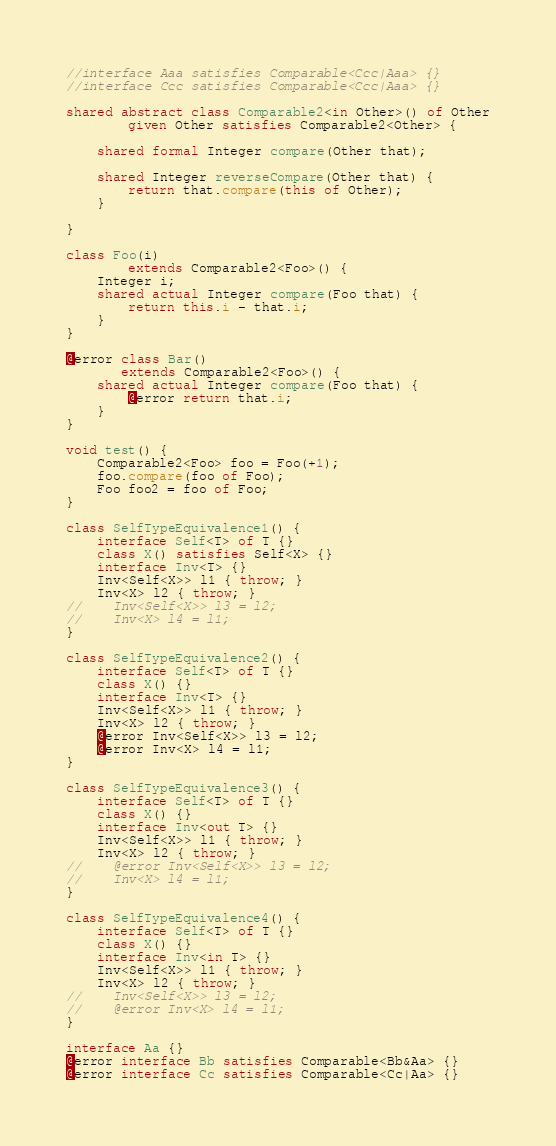Convert code to text. <code><loc_0><loc_0><loc_500><loc_500><_Ceylon_>//interface Aaa satisfies Comparable<Ccc|Aaa> {}
//interface Ccc satisfies Comparable<Ccc|Aaa> {}

shared abstract class Comparable2<in Other>() of Other
        given Other satisfies Comparable2<Other> {
    
    shared formal Integer compare(Other that);
    
    shared Integer reverseCompare(Other that) { 
        return that.compare(this of Other);
    }
    
}

class Foo(i)
        extends Comparable2<Foo>() {
    Integer i;
    shared actual Integer compare(Foo that) {
        return this.i - that.i;
    }
}

@error class Bar()
       extends Comparable2<Foo>() {
    shared actual Integer compare(Foo that) {
        @error return that.i;
    }
}

void test() {
    Comparable2<Foo> foo = Foo(+1);
    foo.compare(foo of Foo);
    Foo foo2 = foo of Foo;
}

class SelfTypeEquivalence1() {
    interface Self<T> of T {}
    class X() satisfies Self<X> {}
    interface Inv<T> {}
    Inv<Self<X>> l1 { throw; }
    Inv<X> l2 { throw; }
//    Inv<Self<X>> l3 = l2;
//    Inv<X> l4 = l1;
}

class SelfTypeEquivalence2() {
    interface Self<T> of T {}
    class X() {}
    interface Inv<T> {}
    Inv<Self<X>> l1 { throw; }
    Inv<X> l2 { throw; }
    @error Inv<Self<X>> l3 = l2;
    @error Inv<X> l4 = l1;
}

class SelfTypeEquivalence3() {
    interface Self<T> of T {}
    class X() {}
    interface Inv<out T> {}
    Inv<Self<X>> l1 { throw; }
    Inv<X> l2 { throw; }
//    @error Inv<Self<X>> l3 = l2;
//    Inv<X> l4 = l1;
}

class SelfTypeEquivalence4() {
    interface Self<T> of T {}
    class X() {}
    interface Inv<in T> {}
    Inv<Self<X>> l1 { throw; }
    Inv<X> l2 { throw; }
//    Inv<Self<X>> l3 = l2;
//    @error Inv<X> l4 = l1;
}

interface Aa {}
@error interface Bb satisfies Comparable<Bb&Aa> {}
@error interface Cc satisfies Comparable<Cc|Aa> {}</code> 